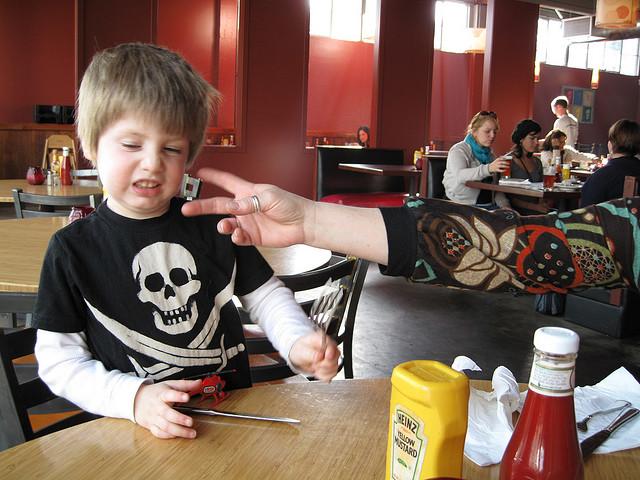Is this scene in a home kitchen?
Keep it brief. No. What is in the yellow bottle?
Keep it brief. Mustard. Is this kid upset?
Write a very short answer. Yes. 